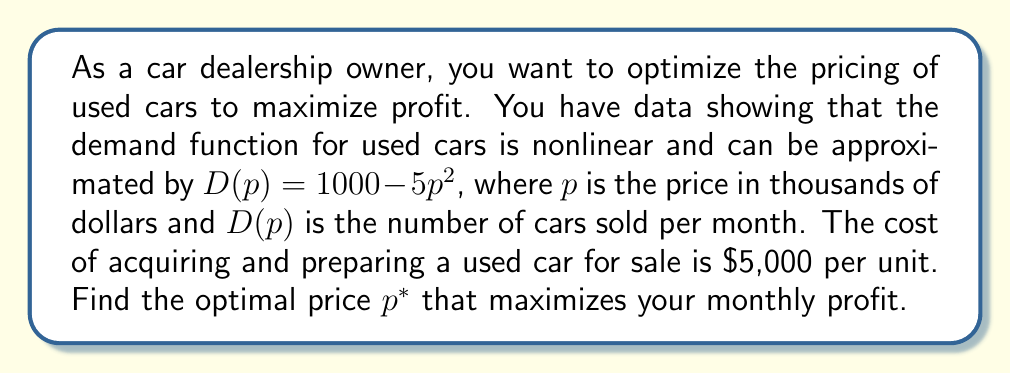Provide a solution to this math problem. Let's approach this step-by-step using nonlinear optimization techniques:

1) First, let's define the profit function. Profit is revenue minus cost:
   $$ \Pi(p) = pD(p) - 5D(p) $$
   where $\Pi(p)$ is the profit in thousands of dollars, $p$ is the price in thousands of dollars, and $5$ is the cost per unit in thousands of dollars.

2) Substitute the demand function:
   $$ \Pi(p) = p(1000 - 5p^2) - 5(1000 - 5p^2) $$

3) Expand the equation:
   $$ \Pi(p) = 1000p - 5p^3 - 5000 + 25p^2 $$

4) To find the maximum profit, we need to find where the derivative of $\Pi(p)$ equals zero:
   $$ \frac{d\Pi}{dp} = 1000 - 15p^2 + 50p $$

5) Set this equal to zero and solve:
   $$ 1000 - 15p^2 + 50p = 0 $$
   $$ 15p^2 - 50p - 1000 = 0 $$

6) This is a quadratic equation. We can solve it using the quadratic formula:
   $$ p = \frac{-b \pm \sqrt{b^2 - 4ac}}{2a} $$
   where $a=15$, $b=-50$, and $c=-1000$

7) Solving this:
   $$ p = \frac{50 \pm \sqrt{2500 + 60000}}{30} = \frac{50 \pm \sqrt{62500}}{30} = \frac{50 \pm 250}{30} $$

8) This gives us two solutions: $p = 10$ or $p = -6.67$. Since price can't be negative, we discard the negative solution.

9) To confirm this is a maximum (not a minimum), we can check the second derivative:
   $$ \frac{d^2\Pi}{dp^2} = -30p + 50 $$
   At $p=10$, this equals $-250$, which is negative, confirming a maximum.

Therefore, the optimal price $p^*$ is 10, or $\$10,000$.
Answer: $\$10,000$ 